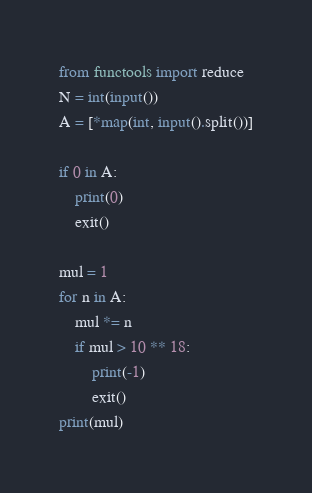<code> <loc_0><loc_0><loc_500><loc_500><_Python_>from functools import reduce
N = int(input())
A = [*map(int, input().split())]

if 0 in A:
    print(0)
    exit()

mul = 1
for n in A:
    mul *= n
    if mul > 10 ** 18:
        print(-1)
        exit()
print(mul)
</code> 